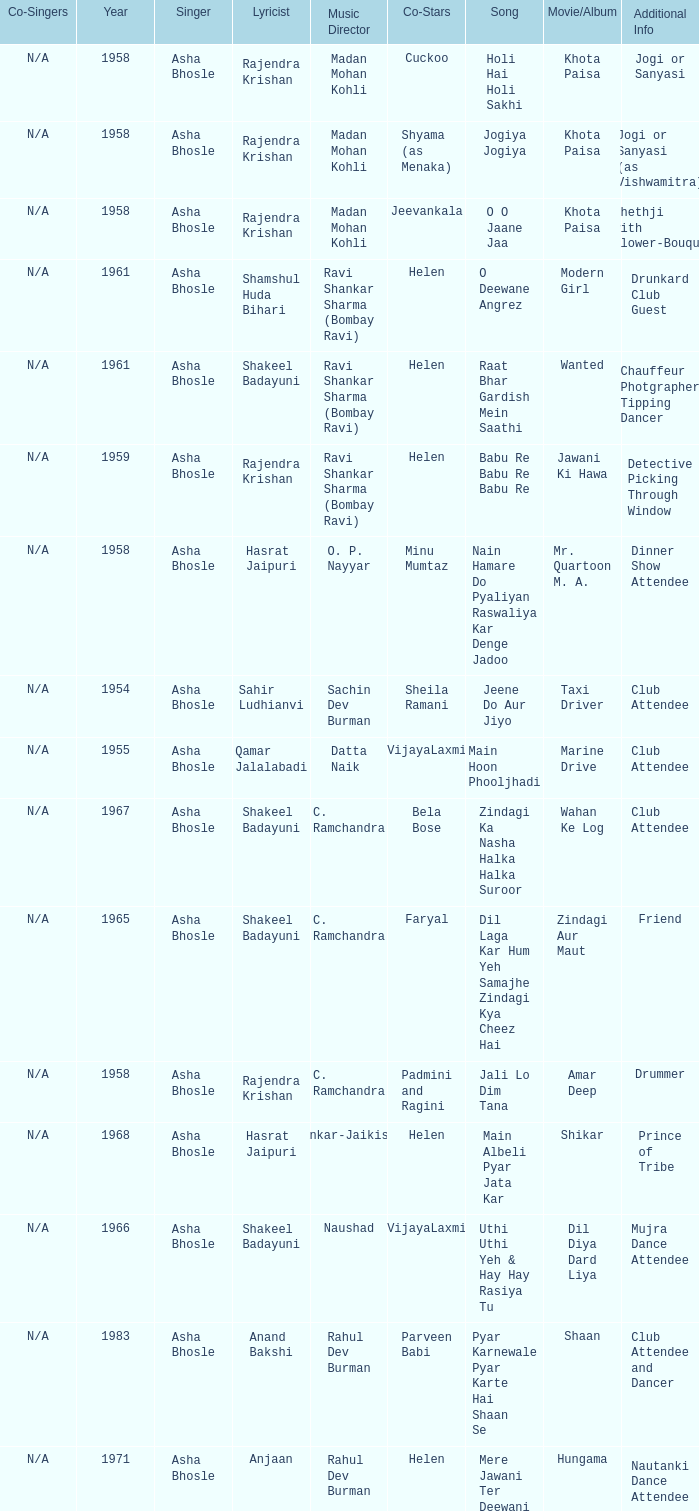What movie did Vijayalaxmi Co-star in and Shakeel Badayuni write the lyrics? Dil Diya Dard Liya. 